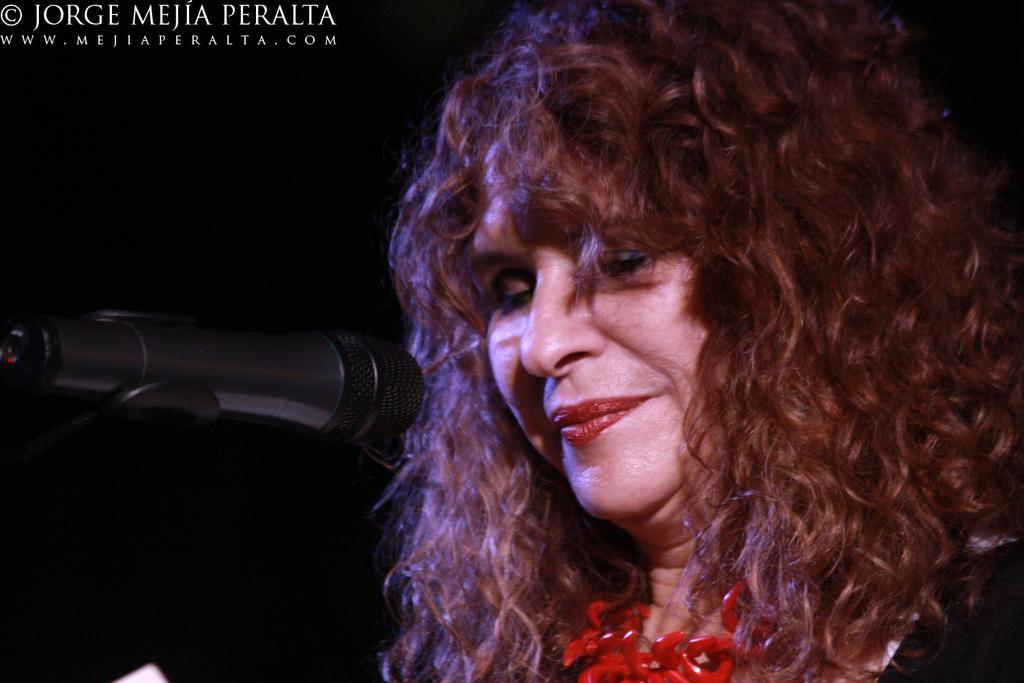Who is present on the right side of the image? There is a woman on the right side of the image. What object is located on the left side of the image? There is a microphone on the left side of the image. How would you describe the background of the image? The background of the image is dark. Where is the text located in the image? The text is at the left top of the image. What type of science experiment is being conducted by the woman's uncle in the image? There is no uncle or science experiment present in the image. What is the pump used for in the image? There is no pump present in the image. 